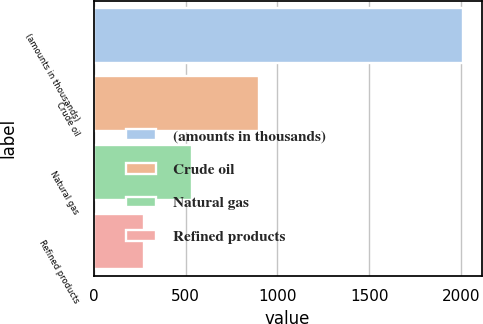<chart> <loc_0><loc_0><loc_500><loc_500><bar_chart><fcel>(amounts in thousands)<fcel>Crude oil<fcel>Natural gas<fcel>Refined products<nl><fcel>2011<fcel>900<fcel>533<fcel>275<nl></chart> 